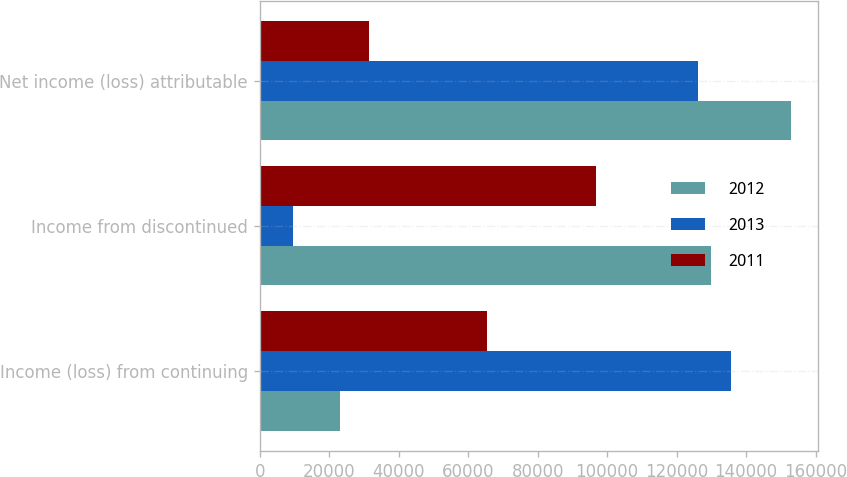<chart> <loc_0><loc_0><loc_500><loc_500><stacked_bar_chart><ecel><fcel>Income (loss) from continuing<fcel>Income from discontinued<fcel>Net income (loss) attributable<nl><fcel>2012<fcel>23126<fcel>129918<fcel>153044<nl><fcel>2013<fcel>135655<fcel>9510<fcel>126145<nl><fcel>2011<fcel>65345<fcel>96761<fcel>31416<nl></chart> 